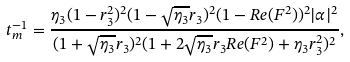Convert formula to latex. <formula><loc_0><loc_0><loc_500><loc_500>t _ { m } ^ { - 1 } = \frac { \eta _ { 3 } ( 1 - r _ { 3 } ^ { 2 } ) ^ { 2 } ( 1 - \sqrt { \eta _ { 3 } } r _ { 3 } ) ^ { 2 } ( 1 - R e ( F ^ { 2 } ) ) ^ { 2 } | \alpha | ^ { 2 } } { ( 1 + \sqrt { \eta _ { 3 } } r _ { 3 } ) ^ { 2 } ( 1 + 2 \sqrt { \eta _ { 3 } } r _ { 3 } R e ( F ^ { 2 } ) + \eta _ { 3 } r _ { 3 } ^ { 2 } ) ^ { 2 } } ,</formula> 